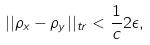Convert formula to latex. <formula><loc_0><loc_0><loc_500><loc_500>| | \rho _ { x } - \rho _ { y } | | _ { t r } < \frac { 1 } { c } 2 \epsilon ,</formula> 